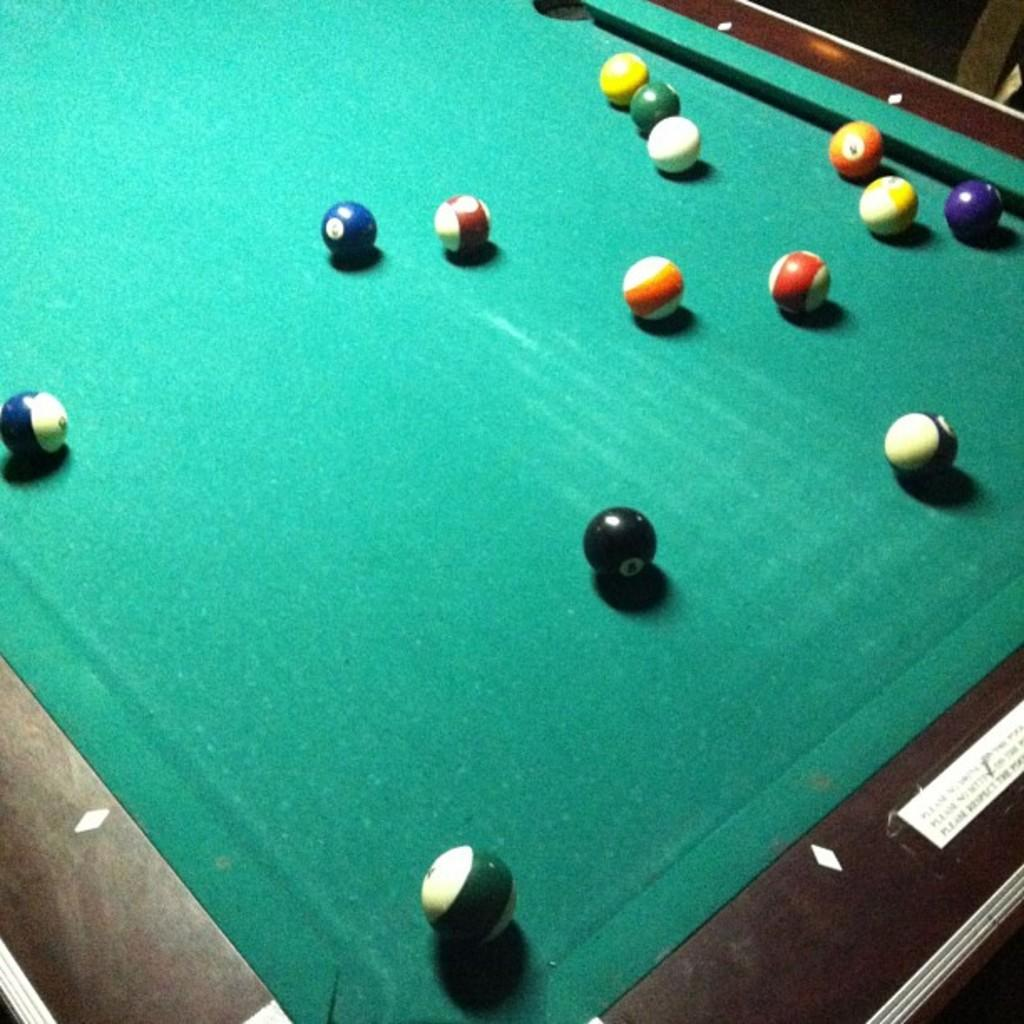What type of game can be played on the board in the image? The board in the image is a billiards board, which is used for playing billiards. What are the small spherical objects in the image? There are billiard balls in the image. What type of pen can be seen in the image? There is no pen present in the image. Can you describe the squirrel playing billiards in the image? There is no squirrel present in the image, and squirrels do not play billiards. 